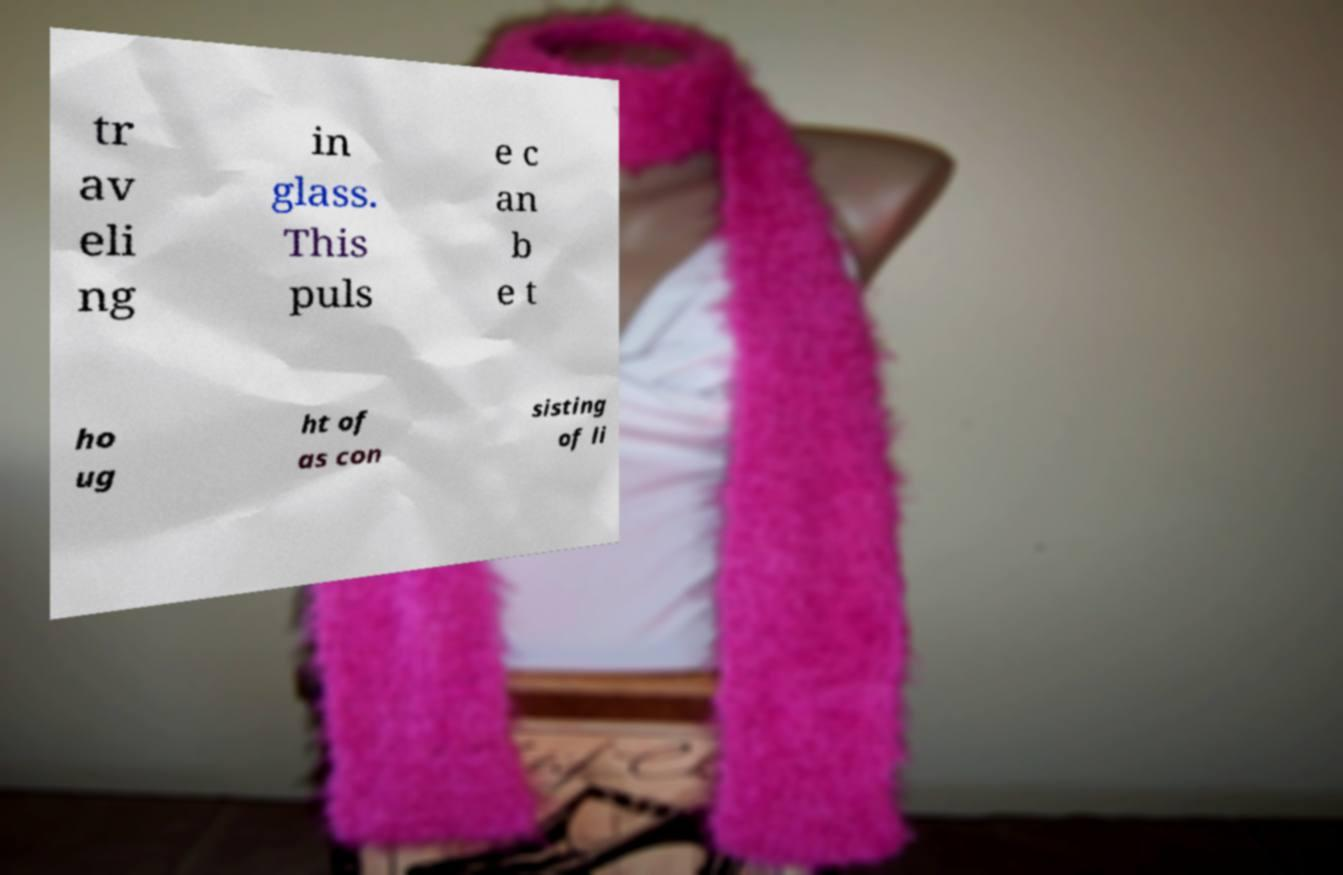What messages or text are displayed in this image? I need them in a readable, typed format. tr av eli ng in glass. This puls e c an b e t ho ug ht of as con sisting of li 